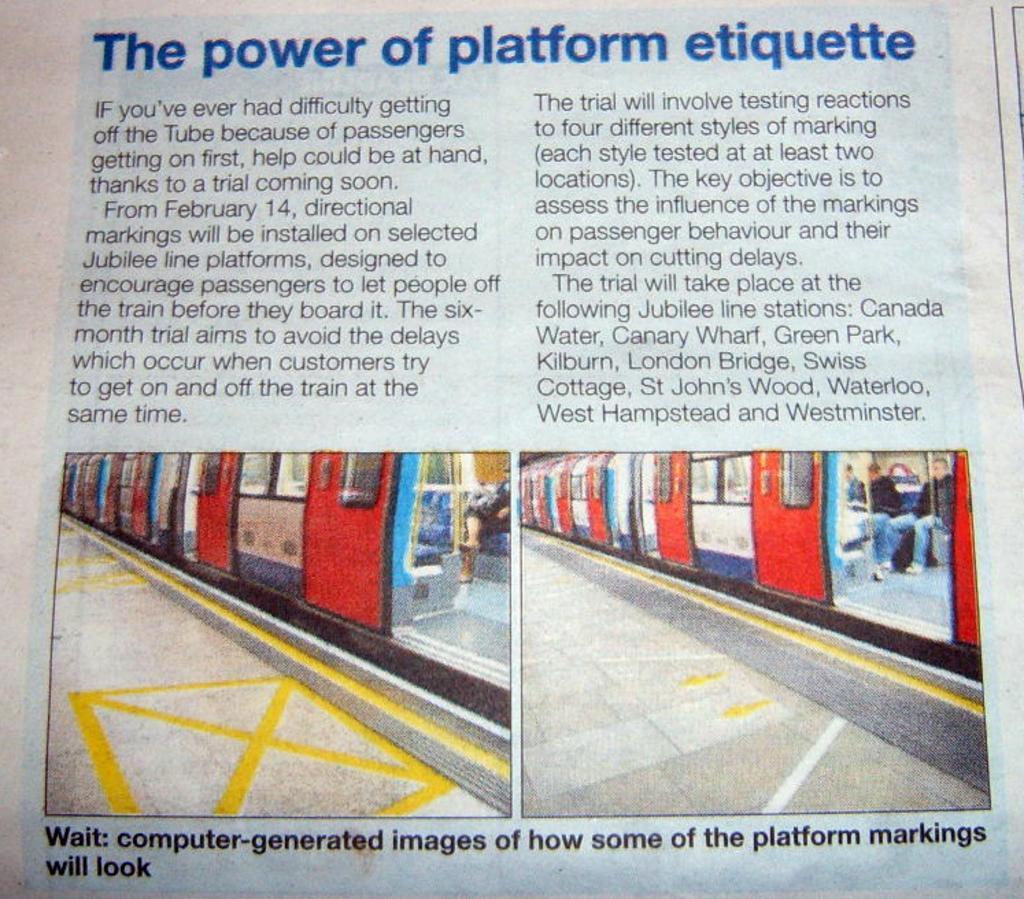Can you describe this image briefly? In this image, we can see a magazine. In this image, we can see some text and two photos. In the photos, we can see trains with windows. Here we can see few people and platforms. 